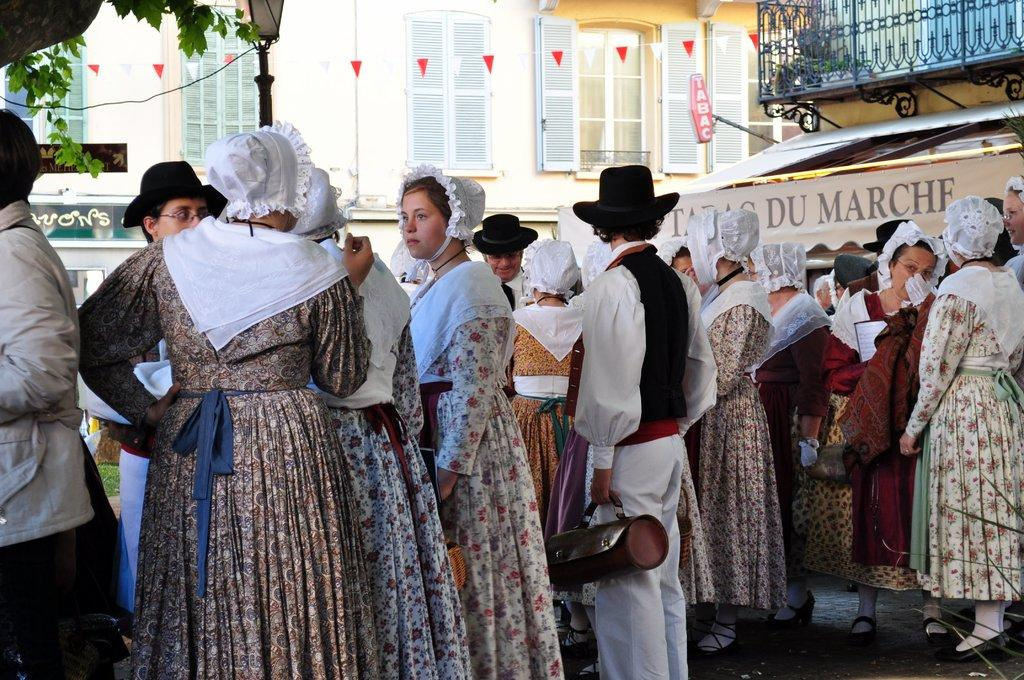How many people are present in the image? There is a group of people standing in the image. What can be seen in the background of the image? There are street lights, at least one building, a metal grill, a hoarding, a glass window, and plants in the background of the image. How does the comparison between the people and the plants in the image lead to the death of a character? There is no comparison between the people and the plants in the image, nor is there any character or death depicted in the image. 